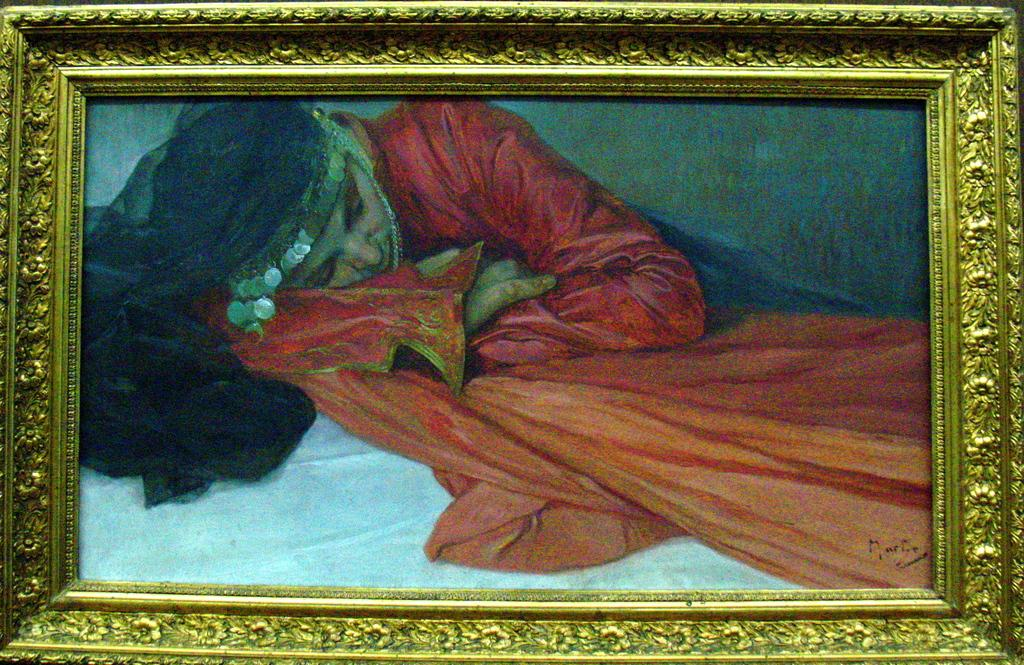What is the main object in the image? There is a frame in the image. What is inside the frame? The frame contains a picture. What is the subject of the picture? The picture depicts a lying woman. What is the woman wearing in the picture? The woman is wearing a red dress. What can be seen at the bottom of the picture? There is a white bed at the bottom of the picture. What type of insurance policy is the woman holding in the picture? There is no insurance policy visible in the picture; the woman is lying down and wearing a red dress. How many fingers can be seen on the woman's hand in the picture? The number of fingers on the woman's hand cannot be determined from the image, as her hands are not visible. 